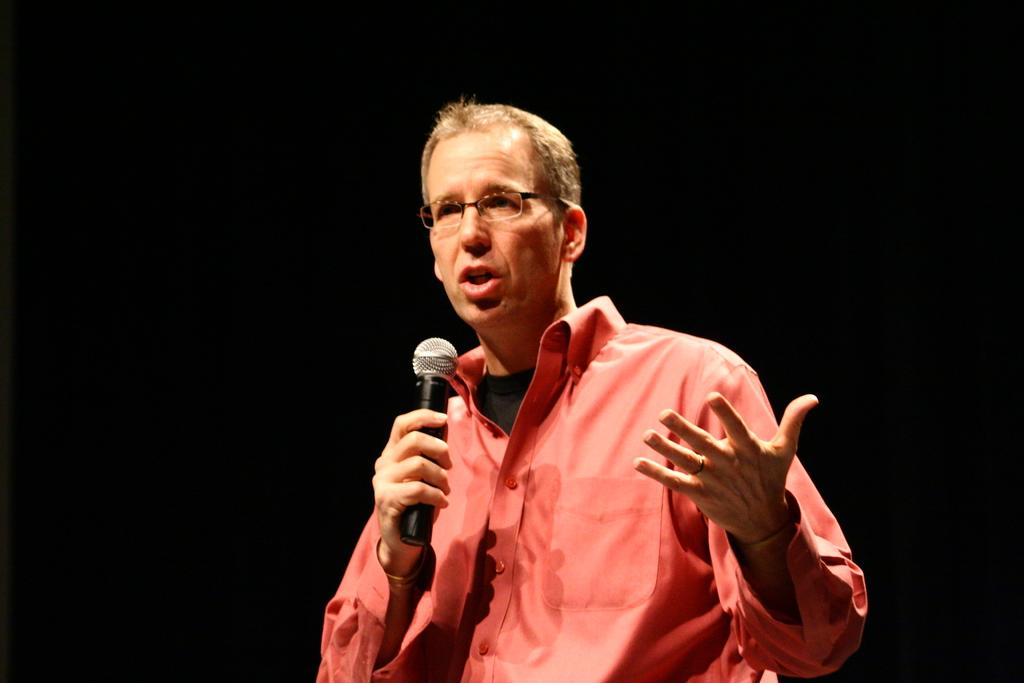What is the main subject of the image? There is a man in the image. Where is the man positioned in the image? The man is standing in the center of the image. What is the man holding in the image? The man is holding a mic. What type of cattle can be seen grazing in the background of the image? There is no cattle or background visible in the image; it only features a man standing in the center holding a mic. 